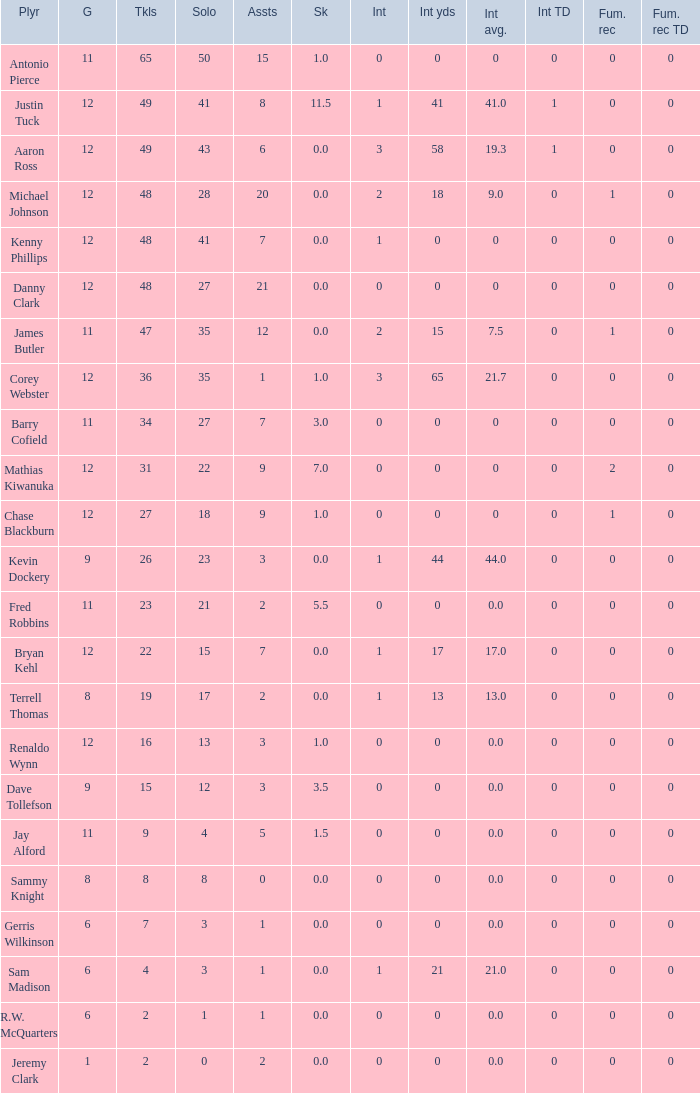Name the least amount of tackles for danny clark 48.0. 